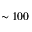<formula> <loc_0><loc_0><loc_500><loc_500>\sim 1 0 0</formula> 